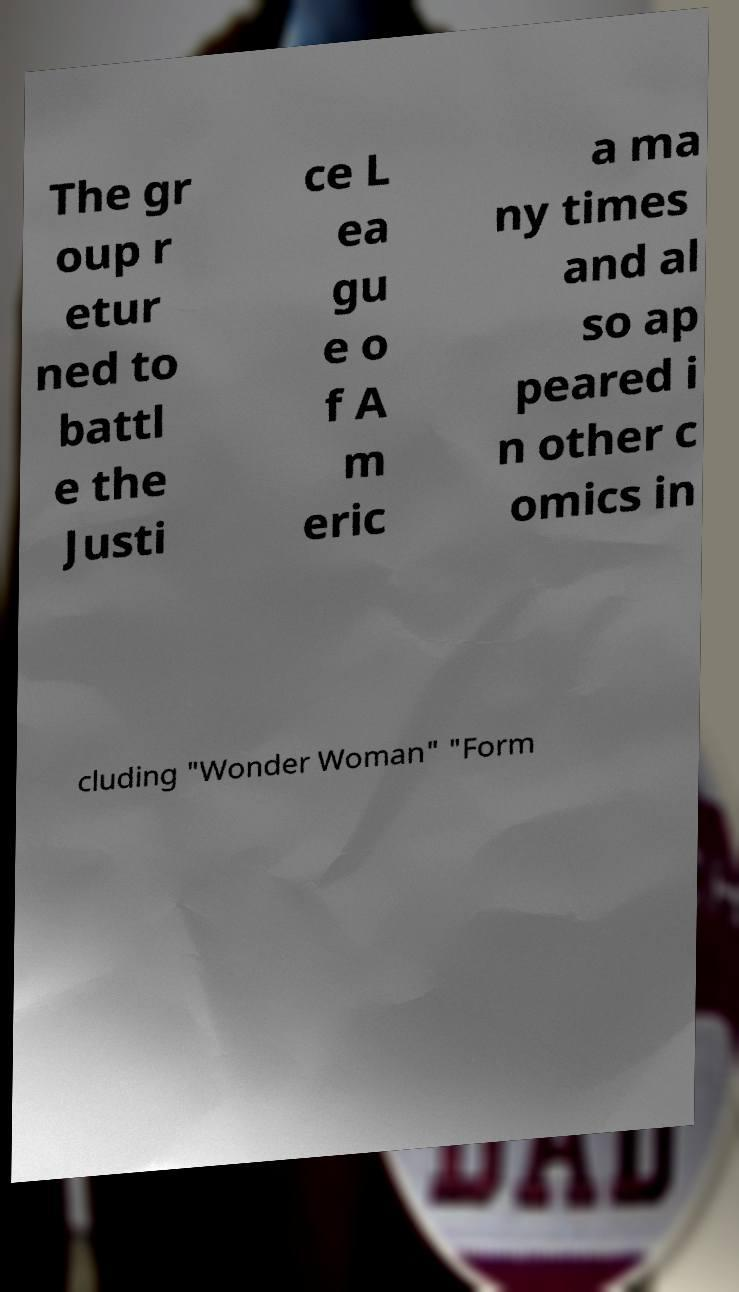Please read and relay the text visible in this image. What does it say? The gr oup r etur ned to battl e the Justi ce L ea gu e o f A m eric a ma ny times and al so ap peared i n other c omics in cluding "Wonder Woman" "Form 